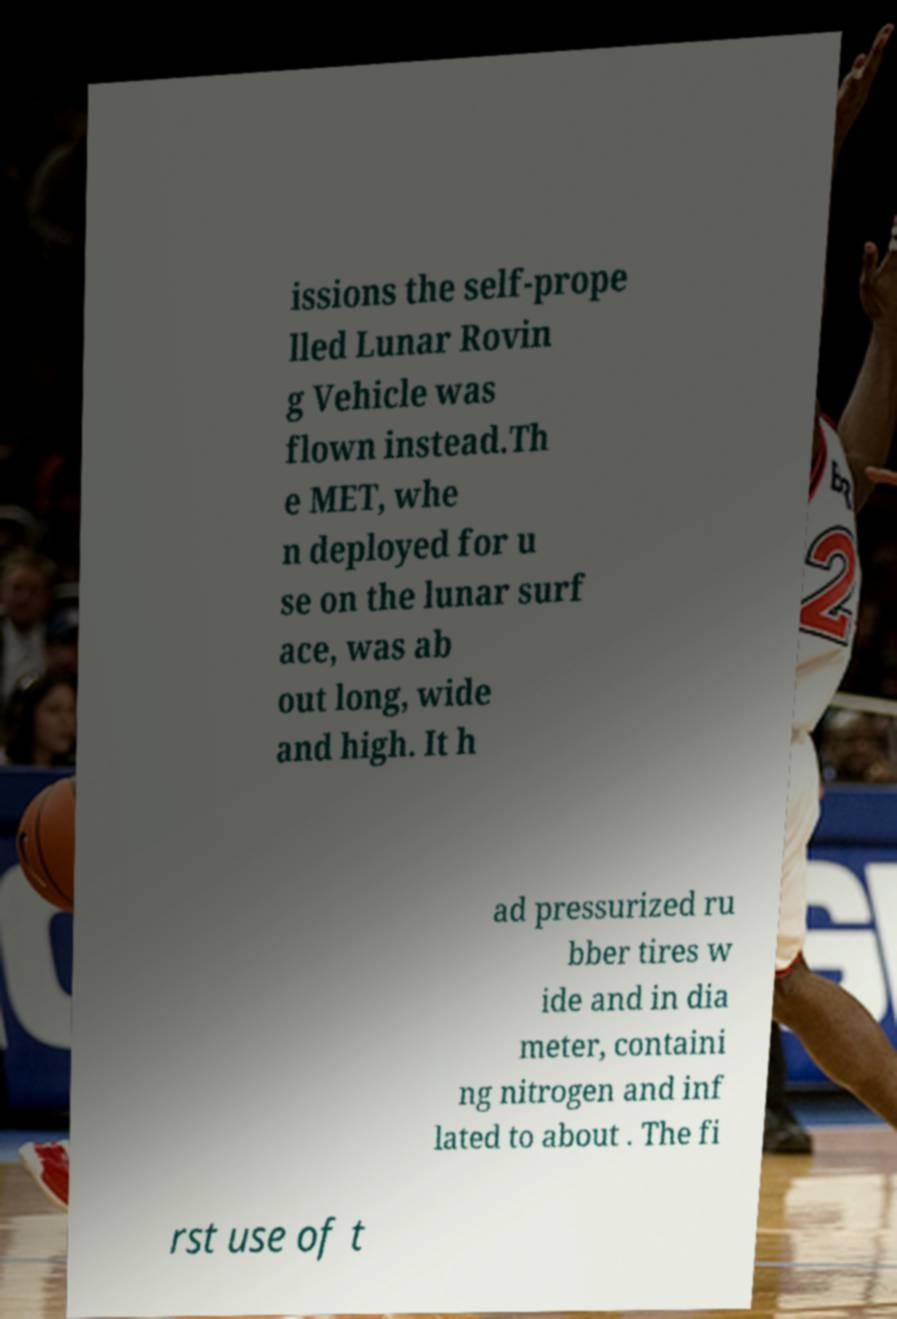What messages or text are displayed in this image? I need them in a readable, typed format. issions the self-prope lled Lunar Rovin g Vehicle was flown instead.Th e MET, whe n deployed for u se on the lunar surf ace, was ab out long, wide and high. It h ad pressurized ru bber tires w ide and in dia meter, containi ng nitrogen and inf lated to about . The fi rst use of t 